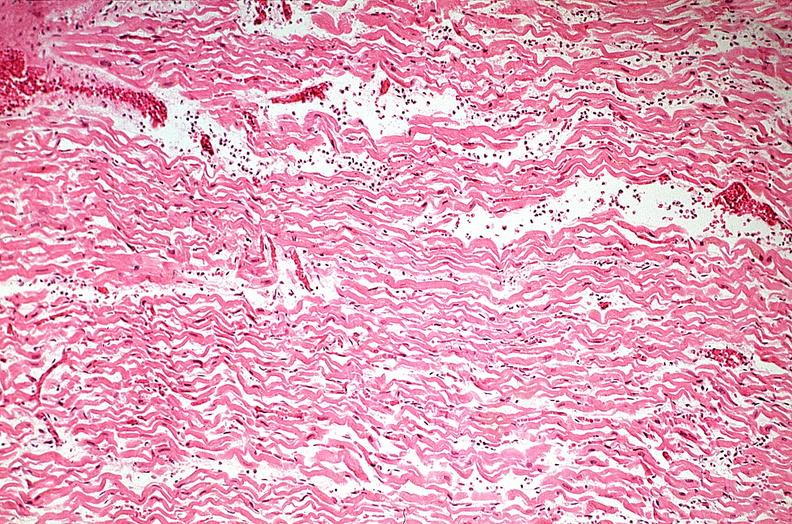does this image show heart, myocardial infarction, wavey fiber change, necrtosis, hemorrhage, and dissection?
Answer the question using a single word or phrase. Yes 